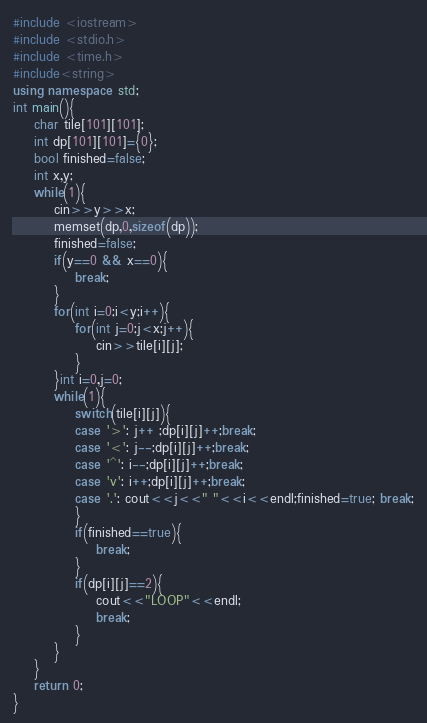Convert code to text. <code><loc_0><loc_0><loc_500><loc_500><_C++_>#include <iostream>
#include <stdio.h>
#include <time.h>
#include<string>
using namespace std;
int main(){
	char tile[101][101];
	int dp[101][101]={0};
	bool finished=false;
	int x,y;
	while(1){
		cin>>y>>x;
		memset(dp,0,sizeof(dp));
		finished=false;
		if(y==0 && x==0){
			break;
		}
		for(int i=0;i<y;i++){
			for(int j=0;j<x;j++){
				cin>>tile[i][j];
			}
		}int i=0,j=0;
		while(1){
			switch(tile[i][j]){
			case '>': j++ ;dp[i][j]++;break;
			case '<': j--;dp[i][j]++;break;
			case '^': i--;dp[i][j]++;break;
			case 'v': i++;dp[i][j]++;break;
			case '.': cout<<j<<" "<<i<<endl;finished=true; break;
			}
			if(finished==true){
				break;
			}
			if(dp[i][j]==2){
				cout<<"LOOP"<<endl;
				break;
			}
		}
	}
	return 0;
}</code> 